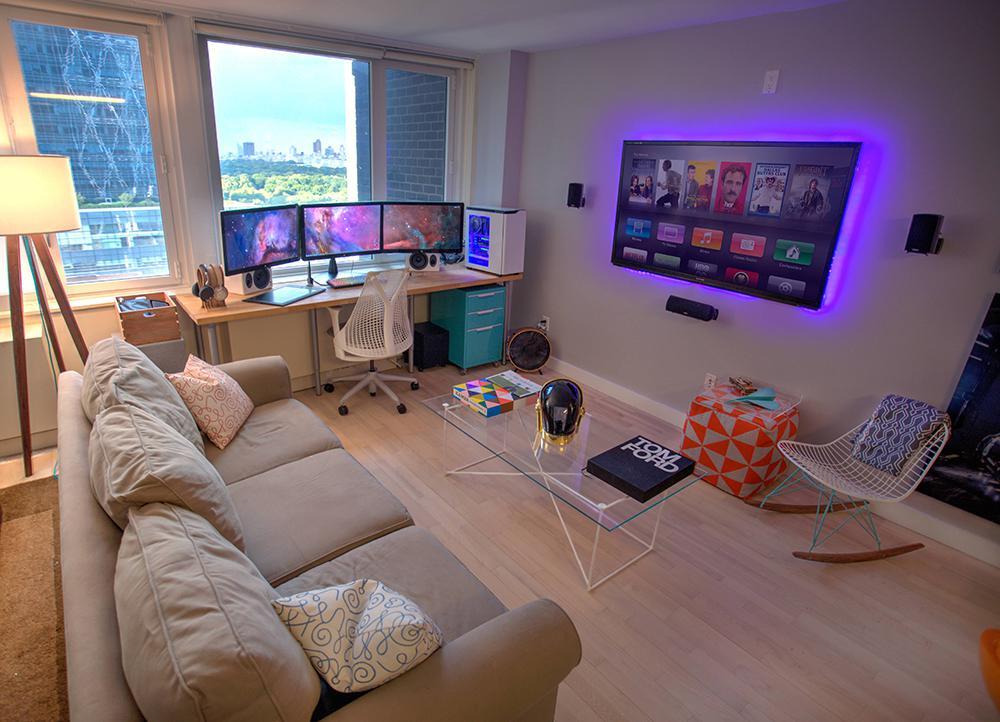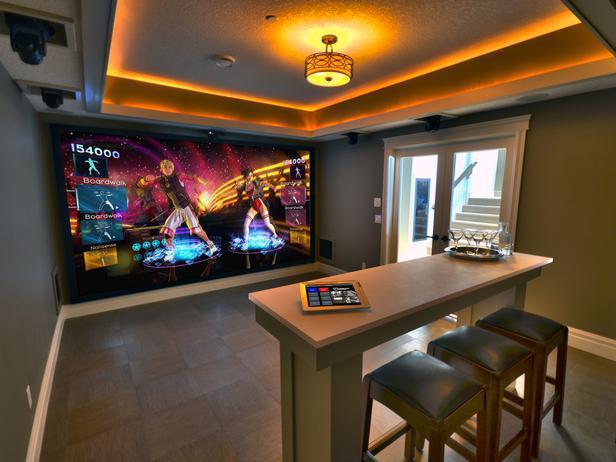The first image is the image on the left, the second image is the image on the right. Given the left and right images, does the statement "The flat screened TV in front of the sitting area is mounted on the wall." hold true? Answer yes or no. Yes. The first image is the image on the left, the second image is the image on the right. For the images shown, is this caption "Each image shows one wide screen on a wall, with seating in front of it, and one image shows a screen surrounded by a blue glow." true? Answer yes or no. Yes. 